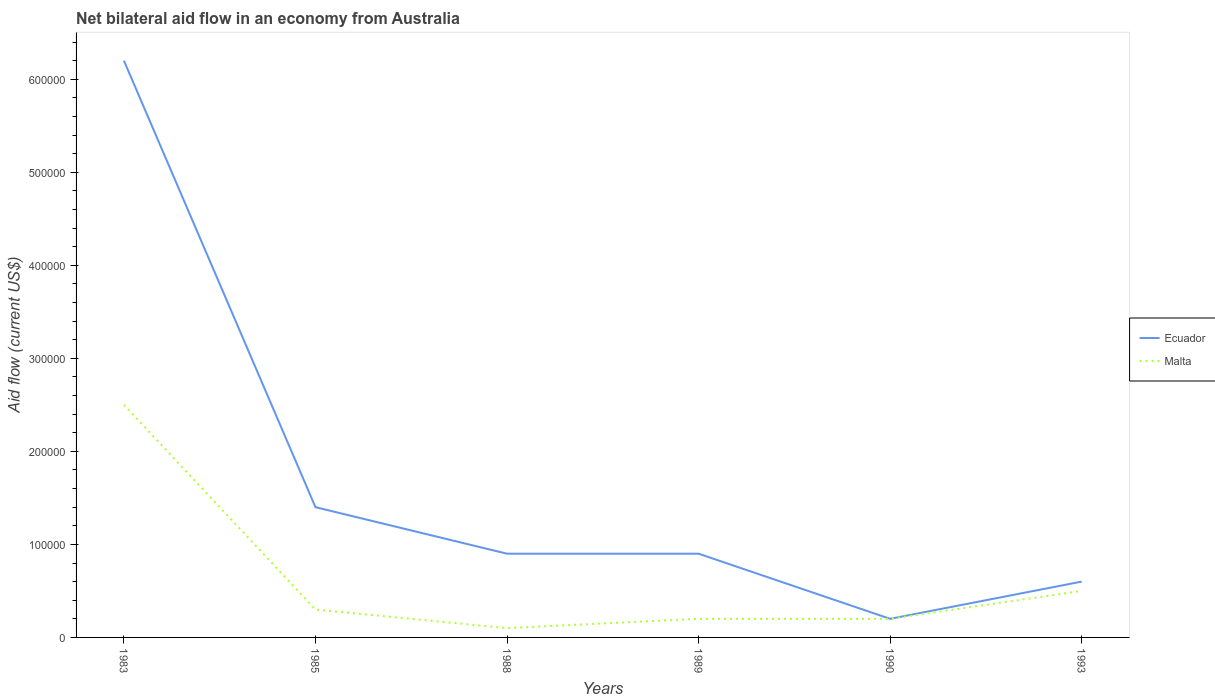How many different coloured lines are there?
Provide a short and direct response. 2. Is the number of lines equal to the number of legend labels?
Offer a very short reply. Yes. In which year was the net bilateral aid flow in Malta maximum?
Give a very brief answer. 1988. What is the difference between the highest and the second highest net bilateral aid flow in Ecuador?
Your answer should be very brief. 6.00e+05. Is the net bilateral aid flow in Ecuador strictly greater than the net bilateral aid flow in Malta over the years?
Provide a succinct answer. No. What is the difference between two consecutive major ticks on the Y-axis?
Your response must be concise. 1.00e+05. Does the graph contain grids?
Offer a terse response. No. Where does the legend appear in the graph?
Give a very brief answer. Center right. How many legend labels are there?
Make the answer very short. 2. What is the title of the graph?
Your response must be concise. Net bilateral aid flow in an economy from Australia. What is the Aid flow (current US$) in Ecuador in 1983?
Your answer should be compact. 6.20e+05. What is the Aid flow (current US$) of Malta in 1983?
Your response must be concise. 2.50e+05. What is the Aid flow (current US$) of Malta in 1985?
Give a very brief answer. 3.00e+04. What is the Aid flow (current US$) of Ecuador in 1989?
Keep it short and to the point. 9.00e+04. What is the Aid flow (current US$) of Malta in 1989?
Your response must be concise. 2.00e+04. What is the Aid flow (current US$) in Ecuador in 1990?
Provide a succinct answer. 2.00e+04. What is the Aid flow (current US$) in Malta in 1990?
Ensure brevity in your answer.  2.00e+04. Across all years, what is the maximum Aid flow (current US$) of Ecuador?
Offer a very short reply. 6.20e+05. Across all years, what is the minimum Aid flow (current US$) in Malta?
Ensure brevity in your answer.  10000. What is the total Aid flow (current US$) of Ecuador in the graph?
Ensure brevity in your answer.  1.02e+06. What is the difference between the Aid flow (current US$) of Ecuador in 1983 and that in 1988?
Provide a short and direct response. 5.30e+05. What is the difference between the Aid flow (current US$) of Malta in 1983 and that in 1988?
Your response must be concise. 2.40e+05. What is the difference between the Aid flow (current US$) of Ecuador in 1983 and that in 1989?
Offer a very short reply. 5.30e+05. What is the difference between the Aid flow (current US$) of Ecuador in 1983 and that in 1993?
Offer a very short reply. 5.60e+05. What is the difference between the Aid flow (current US$) of Malta in 1983 and that in 1993?
Your response must be concise. 2.00e+05. What is the difference between the Aid flow (current US$) of Ecuador in 1985 and that in 1988?
Offer a terse response. 5.00e+04. What is the difference between the Aid flow (current US$) of Malta in 1985 and that in 1988?
Your response must be concise. 2.00e+04. What is the difference between the Aid flow (current US$) of Ecuador in 1985 and that in 1990?
Keep it short and to the point. 1.20e+05. What is the difference between the Aid flow (current US$) in Malta in 1985 and that in 1990?
Ensure brevity in your answer.  10000. What is the difference between the Aid flow (current US$) of Ecuador in 1985 and that in 1993?
Provide a succinct answer. 8.00e+04. What is the difference between the Aid flow (current US$) in Malta in 1988 and that in 1989?
Provide a succinct answer. -10000. What is the difference between the Aid flow (current US$) in Ecuador in 1988 and that in 1990?
Your response must be concise. 7.00e+04. What is the difference between the Aid flow (current US$) in Ecuador in 1988 and that in 1993?
Keep it short and to the point. 3.00e+04. What is the difference between the Aid flow (current US$) in Ecuador in 1989 and that in 1993?
Offer a terse response. 3.00e+04. What is the difference between the Aid flow (current US$) of Malta in 1989 and that in 1993?
Provide a succinct answer. -3.00e+04. What is the difference between the Aid flow (current US$) in Ecuador in 1983 and the Aid flow (current US$) in Malta in 1985?
Your answer should be compact. 5.90e+05. What is the difference between the Aid flow (current US$) of Ecuador in 1983 and the Aid flow (current US$) of Malta in 1990?
Make the answer very short. 6.00e+05. What is the difference between the Aid flow (current US$) of Ecuador in 1983 and the Aid flow (current US$) of Malta in 1993?
Give a very brief answer. 5.70e+05. What is the difference between the Aid flow (current US$) in Ecuador in 1988 and the Aid flow (current US$) in Malta in 1989?
Your answer should be compact. 7.00e+04. What is the difference between the Aid flow (current US$) in Ecuador in 1988 and the Aid flow (current US$) in Malta in 1993?
Make the answer very short. 4.00e+04. What is the difference between the Aid flow (current US$) of Ecuador in 1989 and the Aid flow (current US$) of Malta in 1990?
Offer a terse response. 7.00e+04. What is the difference between the Aid flow (current US$) of Ecuador in 1989 and the Aid flow (current US$) of Malta in 1993?
Give a very brief answer. 4.00e+04. What is the average Aid flow (current US$) of Ecuador per year?
Ensure brevity in your answer.  1.70e+05. What is the average Aid flow (current US$) in Malta per year?
Ensure brevity in your answer.  6.33e+04. In the year 1983, what is the difference between the Aid flow (current US$) of Ecuador and Aid flow (current US$) of Malta?
Provide a short and direct response. 3.70e+05. In the year 1989, what is the difference between the Aid flow (current US$) in Ecuador and Aid flow (current US$) in Malta?
Ensure brevity in your answer.  7.00e+04. In the year 1990, what is the difference between the Aid flow (current US$) of Ecuador and Aid flow (current US$) of Malta?
Make the answer very short. 0. What is the ratio of the Aid flow (current US$) in Ecuador in 1983 to that in 1985?
Your answer should be very brief. 4.43. What is the ratio of the Aid flow (current US$) of Malta in 1983 to that in 1985?
Your answer should be very brief. 8.33. What is the ratio of the Aid flow (current US$) of Ecuador in 1983 to that in 1988?
Provide a short and direct response. 6.89. What is the ratio of the Aid flow (current US$) in Malta in 1983 to that in 1988?
Keep it short and to the point. 25. What is the ratio of the Aid flow (current US$) in Ecuador in 1983 to that in 1989?
Provide a short and direct response. 6.89. What is the ratio of the Aid flow (current US$) of Ecuador in 1983 to that in 1990?
Offer a very short reply. 31. What is the ratio of the Aid flow (current US$) in Ecuador in 1983 to that in 1993?
Provide a short and direct response. 10.33. What is the ratio of the Aid flow (current US$) of Ecuador in 1985 to that in 1988?
Ensure brevity in your answer.  1.56. What is the ratio of the Aid flow (current US$) of Malta in 1985 to that in 1988?
Keep it short and to the point. 3. What is the ratio of the Aid flow (current US$) in Ecuador in 1985 to that in 1989?
Provide a short and direct response. 1.56. What is the ratio of the Aid flow (current US$) of Ecuador in 1985 to that in 1990?
Ensure brevity in your answer.  7. What is the ratio of the Aid flow (current US$) of Ecuador in 1985 to that in 1993?
Offer a very short reply. 2.33. What is the ratio of the Aid flow (current US$) in Ecuador in 1988 to that in 1990?
Give a very brief answer. 4.5. What is the ratio of the Aid flow (current US$) of Malta in 1988 to that in 1993?
Offer a very short reply. 0.2. What is the ratio of the Aid flow (current US$) in Malta in 1989 to that in 1990?
Keep it short and to the point. 1. What is the ratio of the Aid flow (current US$) of Ecuador in 1989 to that in 1993?
Offer a terse response. 1.5. What is the ratio of the Aid flow (current US$) of Ecuador in 1990 to that in 1993?
Give a very brief answer. 0.33. 